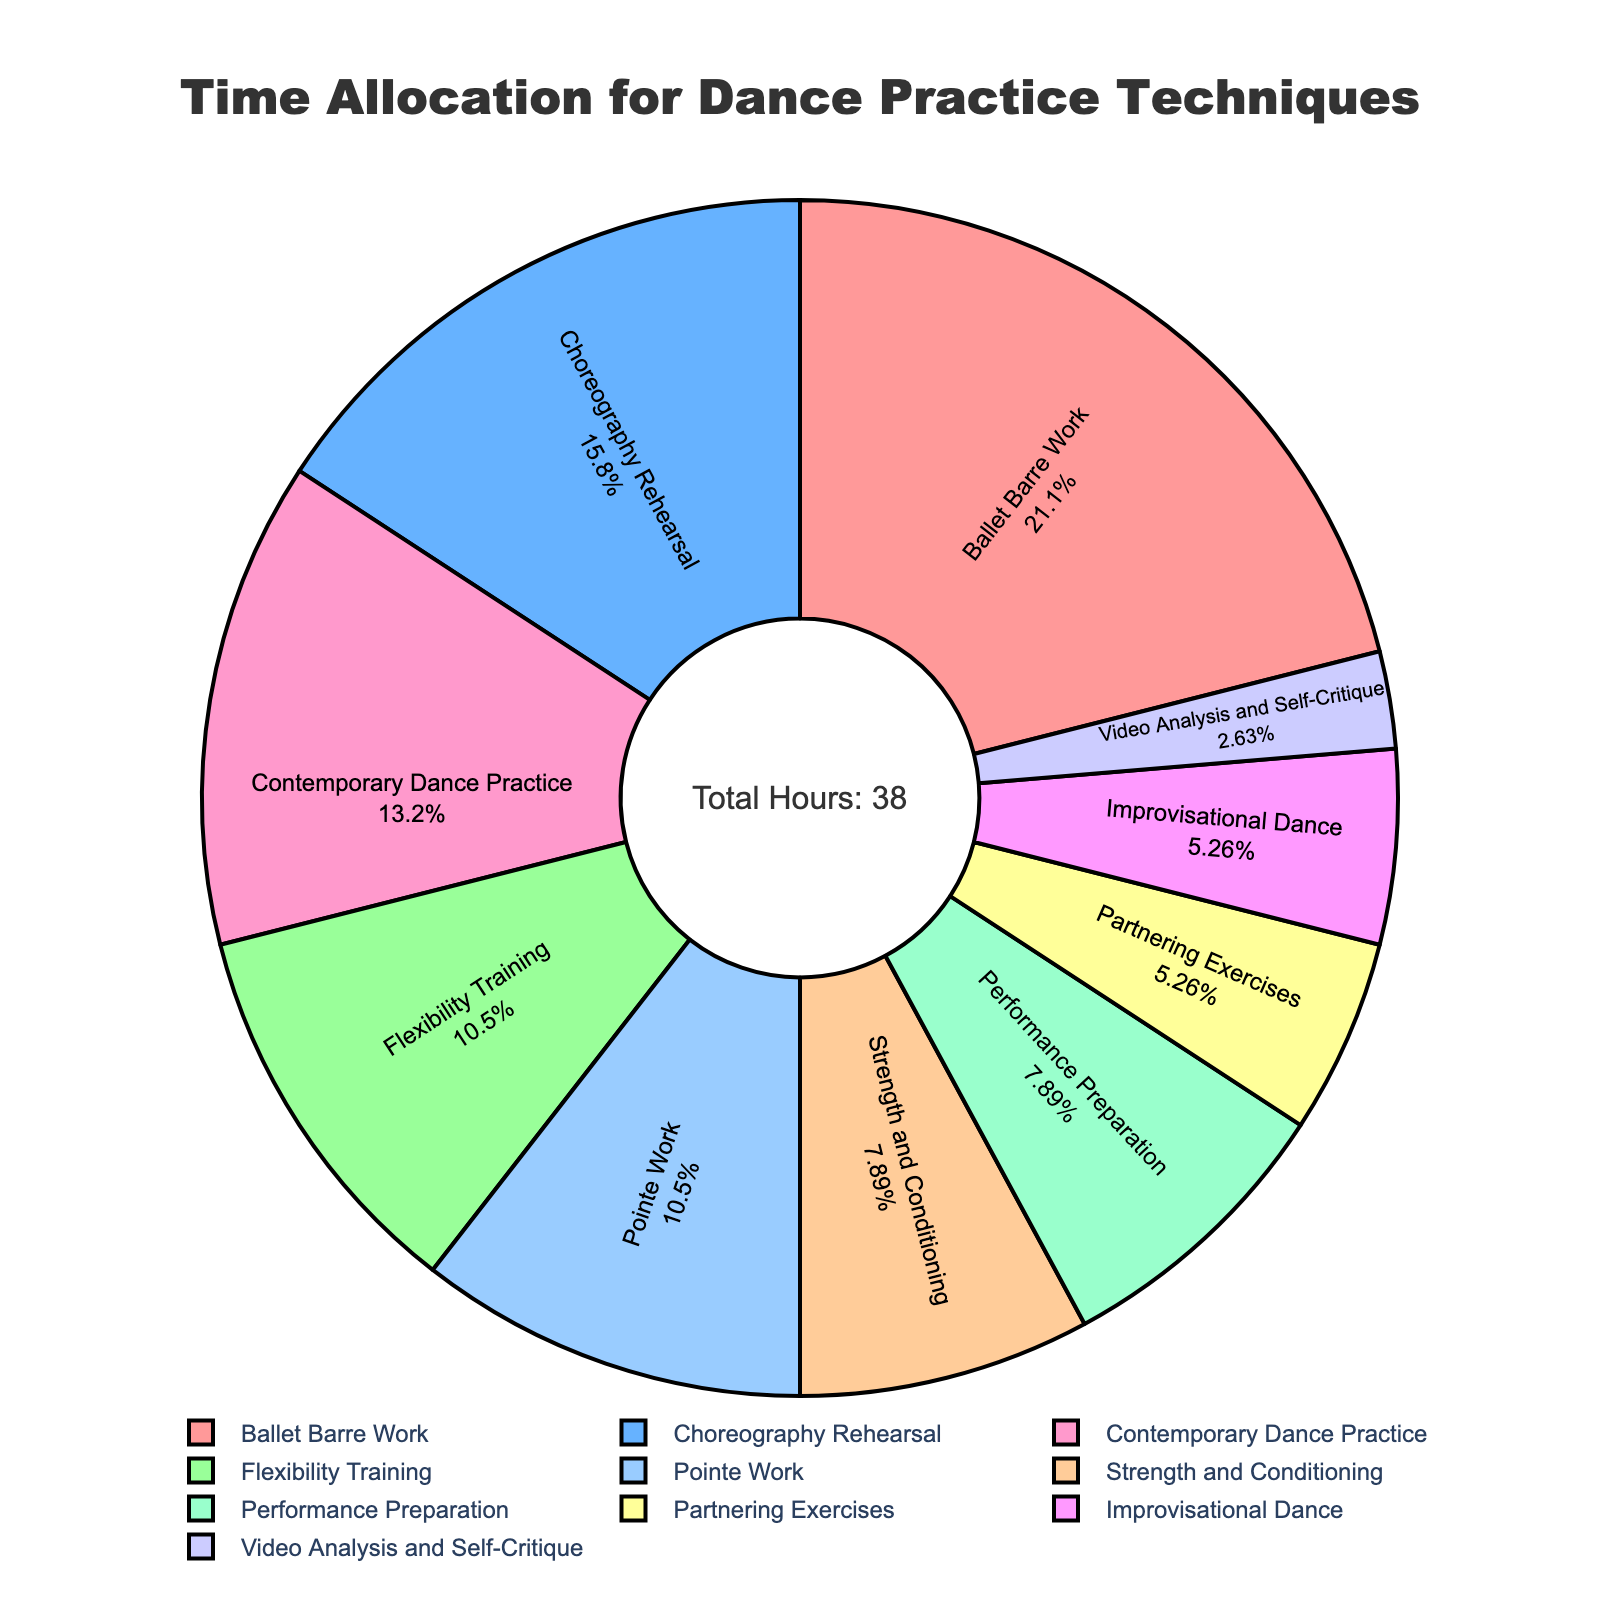What technique takes up the most time per week? The pie chart shows different dance practice techniques and their respective allocation of hours per week. The segment for Ballet Barre Work appears the largest.
Answer: Ballet Barre Work Which techniques have the same amount of time allocated per week? By looking at the size of the pie segments, it is clear that Improvisational Dance and Partnering Exercises have equal-sized slices in the pie chart, indicating they both have 2 hours per week.
Answer: Improvisational Dance and Partnering Exercises How much total time is spent on Flexibility Training and Pointe Work combined? According to the chart, Flexibility Training is allocated 4 hours, and Pointe Work is also allocated 4 hours. Adding them together gives 4 + 4 = 8.
Answer: 8 hours Which technique has the lowest time allocation, and how much time is it? The smallest segment in the pie chart corresponds to Video Analysis and Self-Critique, which shows that it has 1 hour per week.
Answer: Video Analysis and Self-Critique, 1 hour What is the total percentage of time allocated to Contemporary Dance Practice and Performance Preparation combined? Contemporary Dance Practice has 5 hours, and Performance Preparation has 3 hours. The total hours per week are 38. The combined percentage is (5+3)/38 * 100 = 21.05%.
Answer: 21.05% Compare the time allocated to Ballet Barre Work and Choreography Rehearsal. Which is greater and by how much? Ballet Barre Work has 8 hours while Choreography Rehearsal has 6 hours. The difference is 8 - 6 = 2 hours. Ballet Barre Work has 2 hours more than Choreography Rehearsal.
Answer: Ballet Barre Work by 2 hours What percentage of the total time is spent on Strength and Conditioning? Strength and Conditioning has 3 hours per week out of a total of 38 hours. The percentage is (3/38) * 100 ≈ 7.89%.
Answer: 7.89% Which category contributes to more weekly practice hours: Pointe Work or Partnering Exercises? Pointe Work has 4 hours while Partnering Exercises have 2 hours. By comparing the sizes, Pointe Work contributes more weekly practice hours.
Answer: Pointe Work Calculate the total percentage of time allocated to Partnering Exercises, Improvisational Dance, and Video Analysis and Self-Critique. Partnering Exercises and Improvisational Dance each have 2 hours while Video Analysis and Self-Critique has 1 hour out of a total 38 hours. The combined percentage is (2+2+1)/38 * 100 ≈ 13.16%.
Answer: 13.16% What is the ratio of hours spent on Choreography Rehearsal to Performance Preparation? Choreography Rehearsal has 6 hours, and Performance Preparation has 3 hours. The ratio is 6:3, which simplifies to 2:1.
Answer: 2:1 